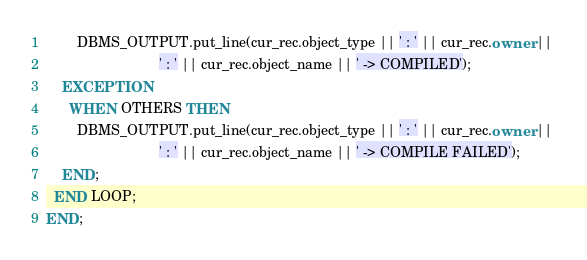<code> <loc_0><loc_0><loc_500><loc_500><_SQL_>        DBMS_OUTPUT.put_line(cur_rec.object_type || ' : ' || cur_rec.owner || 
                             ' : ' || cur_rec.object_name || ' -> COMPILED');      
    EXCEPTION
      WHEN OTHERS THEN
        DBMS_OUTPUT.put_line(cur_rec.object_type || ' : ' || cur_rec.owner || 
                             ' : ' || cur_rec.object_name || ' -> COMPILE FAILED');
    END;
  END LOOP;
END;
</code> 